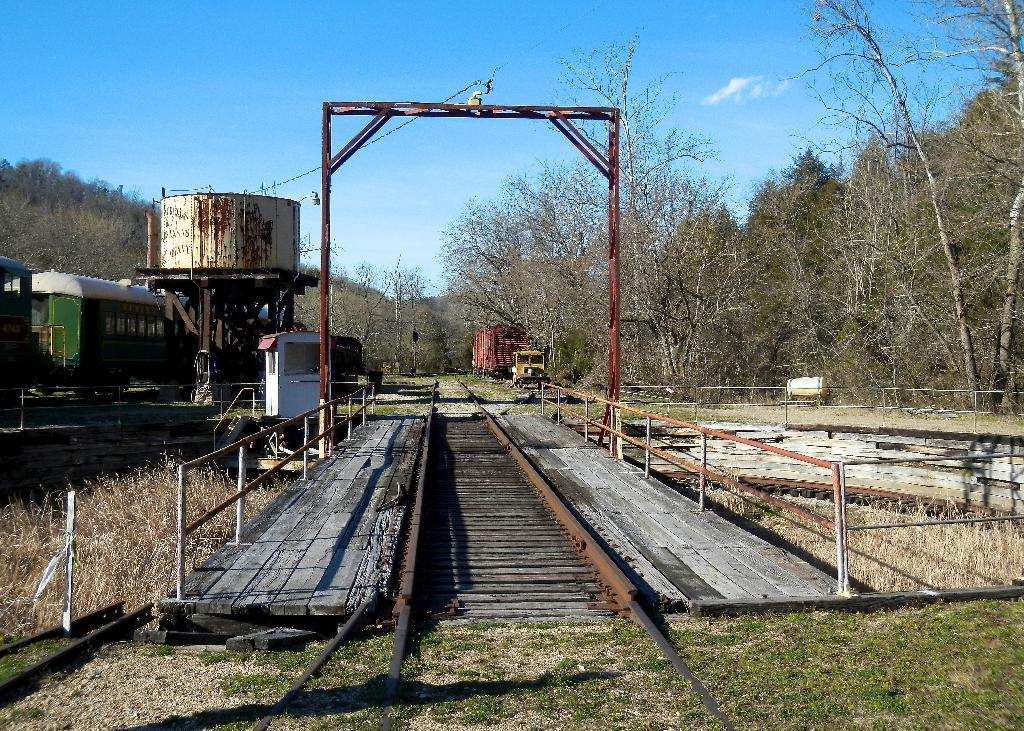What type of structure is present in the image? There is a bridge in the image. What type of vegetation can be seen in the image? There is dry grass and trees in the image. What mode of transportation is visible in the image? There is a train in the image. What part of the natural environment is visible in the image? The sky is visible in the image. Can you tell me how many beggars are visible in the image? There are no beggars present in the image. What type of drink is being offered to the passengers on the train in the image? There is no drink being offered to passengers on the train in the image, as there is no indication of any drinks or passengers. 